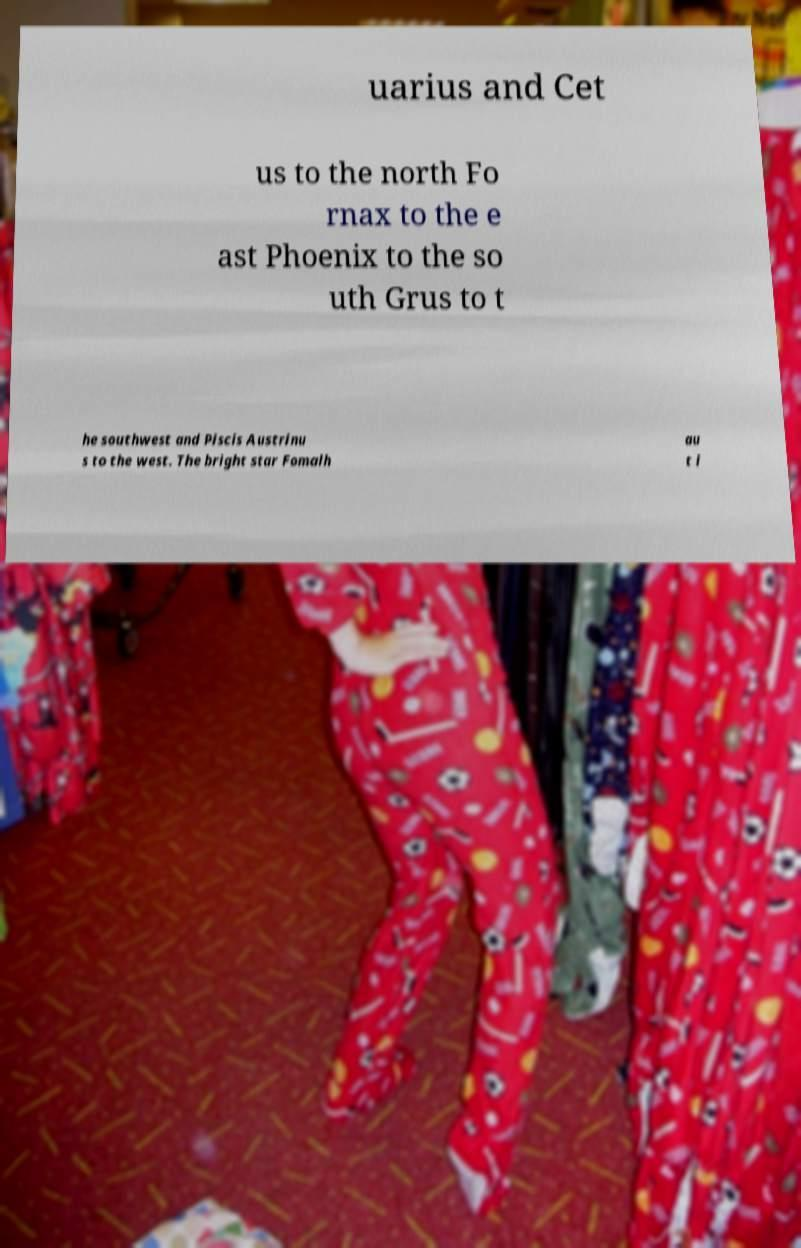Could you extract and type out the text from this image? uarius and Cet us to the north Fo rnax to the e ast Phoenix to the so uth Grus to t he southwest and Piscis Austrinu s to the west. The bright star Fomalh au t i 